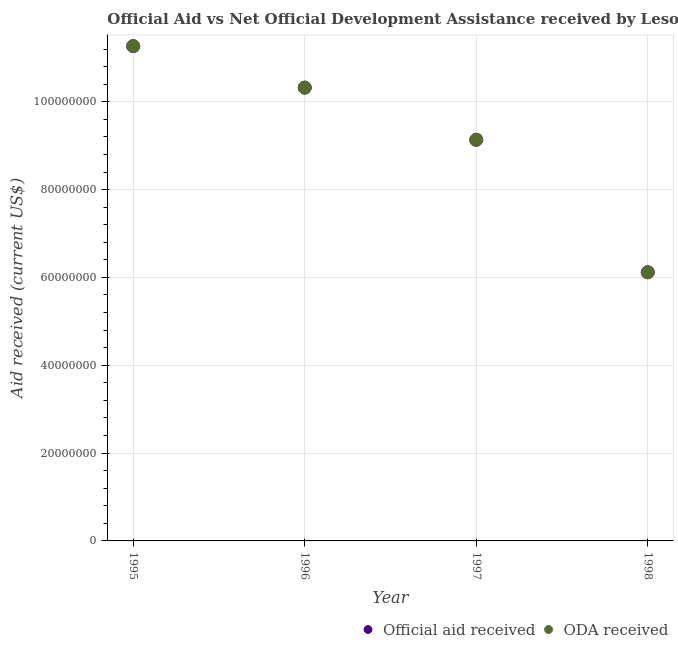Is the number of dotlines equal to the number of legend labels?
Ensure brevity in your answer.  Yes. What is the oda received in 1996?
Your answer should be compact. 1.03e+08. Across all years, what is the maximum oda received?
Your answer should be compact. 1.13e+08. Across all years, what is the minimum oda received?
Ensure brevity in your answer.  6.12e+07. In which year was the oda received maximum?
Keep it short and to the point. 1995. In which year was the oda received minimum?
Keep it short and to the point. 1998. What is the total official aid received in the graph?
Your response must be concise. 3.68e+08. What is the difference between the official aid received in 1995 and that in 1996?
Provide a succinct answer. 9.44e+06. What is the difference between the oda received in 1997 and the official aid received in 1998?
Your answer should be very brief. 3.02e+07. What is the average oda received per year?
Offer a very short reply. 9.21e+07. In how many years, is the official aid received greater than 92000000 US$?
Offer a very short reply. 2. What is the ratio of the oda received in 1995 to that in 1996?
Provide a succinct answer. 1.09. What is the difference between the highest and the second highest oda received?
Your answer should be compact. 9.44e+06. What is the difference between the highest and the lowest oda received?
Provide a succinct answer. 5.15e+07. In how many years, is the official aid received greater than the average official aid received taken over all years?
Provide a short and direct response. 2. Is the sum of the oda received in 1995 and 1996 greater than the maximum official aid received across all years?
Your answer should be compact. Yes. Is the oda received strictly less than the official aid received over the years?
Give a very brief answer. No. How many dotlines are there?
Keep it short and to the point. 2. How many years are there in the graph?
Give a very brief answer. 4. What is the difference between two consecutive major ticks on the Y-axis?
Give a very brief answer. 2.00e+07. Are the values on the major ticks of Y-axis written in scientific E-notation?
Provide a succinct answer. No. Does the graph contain grids?
Ensure brevity in your answer.  Yes. Where does the legend appear in the graph?
Your response must be concise. Bottom right. How many legend labels are there?
Provide a succinct answer. 2. How are the legend labels stacked?
Make the answer very short. Horizontal. What is the title of the graph?
Give a very brief answer. Official Aid vs Net Official Development Assistance received by Lesotho . What is the label or title of the Y-axis?
Ensure brevity in your answer.  Aid received (current US$). What is the Aid received (current US$) in Official aid received in 1995?
Your response must be concise. 1.13e+08. What is the Aid received (current US$) of ODA received in 1995?
Keep it short and to the point. 1.13e+08. What is the Aid received (current US$) of Official aid received in 1996?
Offer a terse response. 1.03e+08. What is the Aid received (current US$) of ODA received in 1996?
Offer a terse response. 1.03e+08. What is the Aid received (current US$) in Official aid received in 1997?
Provide a succinct answer. 9.13e+07. What is the Aid received (current US$) of ODA received in 1997?
Your answer should be compact. 9.13e+07. What is the Aid received (current US$) of Official aid received in 1998?
Offer a terse response. 6.12e+07. What is the Aid received (current US$) in ODA received in 1998?
Your response must be concise. 6.12e+07. Across all years, what is the maximum Aid received (current US$) in Official aid received?
Your answer should be very brief. 1.13e+08. Across all years, what is the maximum Aid received (current US$) in ODA received?
Offer a very short reply. 1.13e+08. Across all years, what is the minimum Aid received (current US$) in Official aid received?
Provide a short and direct response. 6.12e+07. Across all years, what is the minimum Aid received (current US$) of ODA received?
Offer a very short reply. 6.12e+07. What is the total Aid received (current US$) of Official aid received in the graph?
Offer a terse response. 3.68e+08. What is the total Aid received (current US$) of ODA received in the graph?
Provide a succinct answer. 3.68e+08. What is the difference between the Aid received (current US$) in Official aid received in 1995 and that in 1996?
Your answer should be compact. 9.44e+06. What is the difference between the Aid received (current US$) in ODA received in 1995 and that in 1996?
Your response must be concise. 9.44e+06. What is the difference between the Aid received (current US$) in Official aid received in 1995 and that in 1997?
Make the answer very short. 2.13e+07. What is the difference between the Aid received (current US$) in ODA received in 1995 and that in 1997?
Your answer should be very brief. 2.13e+07. What is the difference between the Aid received (current US$) in Official aid received in 1995 and that in 1998?
Your answer should be very brief. 5.15e+07. What is the difference between the Aid received (current US$) of ODA received in 1995 and that in 1998?
Provide a succinct answer. 5.15e+07. What is the difference between the Aid received (current US$) in Official aid received in 1996 and that in 1997?
Ensure brevity in your answer.  1.19e+07. What is the difference between the Aid received (current US$) in ODA received in 1996 and that in 1997?
Keep it short and to the point. 1.19e+07. What is the difference between the Aid received (current US$) in Official aid received in 1996 and that in 1998?
Make the answer very short. 4.20e+07. What is the difference between the Aid received (current US$) of ODA received in 1996 and that in 1998?
Keep it short and to the point. 4.20e+07. What is the difference between the Aid received (current US$) of Official aid received in 1997 and that in 1998?
Keep it short and to the point. 3.02e+07. What is the difference between the Aid received (current US$) in ODA received in 1997 and that in 1998?
Your response must be concise. 3.02e+07. What is the difference between the Aid received (current US$) of Official aid received in 1995 and the Aid received (current US$) of ODA received in 1996?
Provide a short and direct response. 9.44e+06. What is the difference between the Aid received (current US$) in Official aid received in 1995 and the Aid received (current US$) in ODA received in 1997?
Your answer should be very brief. 2.13e+07. What is the difference between the Aid received (current US$) in Official aid received in 1995 and the Aid received (current US$) in ODA received in 1998?
Keep it short and to the point. 5.15e+07. What is the difference between the Aid received (current US$) of Official aid received in 1996 and the Aid received (current US$) of ODA received in 1997?
Your response must be concise. 1.19e+07. What is the difference between the Aid received (current US$) of Official aid received in 1996 and the Aid received (current US$) of ODA received in 1998?
Offer a terse response. 4.20e+07. What is the difference between the Aid received (current US$) in Official aid received in 1997 and the Aid received (current US$) in ODA received in 1998?
Offer a very short reply. 3.02e+07. What is the average Aid received (current US$) of Official aid received per year?
Ensure brevity in your answer.  9.21e+07. What is the average Aid received (current US$) of ODA received per year?
Give a very brief answer. 9.21e+07. In the year 1997, what is the difference between the Aid received (current US$) in Official aid received and Aid received (current US$) in ODA received?
Keep it short and to the point. 0. What is the ratio of the Aid received (current US$) of Official aid received in 1995 to that in 1996?
Make the answer very short. 1.09. What is the ratio of the Aid received (current US$) in ODA received in 1995 to that in 1996?
Your answer should be very brief. 1.09. What is the ratio of the Aid received (current US$) in Official aid received in 1995 to that in 1997?
Your answer should be compact. 1.23. What is the ratio of the Aid received (current US$) of ODA received in 1995 to that in 1997?
Provide a succinct answer. 1.23. What is the ratio of the Aid received (current US$) in Official aid received in 1995 to that in 1998?
Offer a terse response. 1.84. What is the ratio of the Aid received (current US$) of ODA received in 1995 to that in 1998?
Offer a terse response. 1.84. What is the ratio of the Aid received (current US$) in Official aid received in 1996 to that in 1997?
Ensure brevity in your answer.  1.13. What is the ratio of the Aid received (current US$) in ODA received in 1996 to that in 1997?
Provide a succinct answer. 1.13. What is the ratio of the Aid received (current US$) in Official aid received in 1996 to that in 1998?
Make the answer very short. 1.69. What is the ratio of the Aid received (current US$) of ODA received in 1996 to that in 1998?
Your response must be concise. 1.69. What is the ratio of the Aid received (current US$) in Official aid received in 1997 to that in 1998?
Offer a very short reply. 1.49. What is the ratio of the Aid received (current US$) in ODA received in 1997 to that in 1998?
Provide a succinct answer. 1.49. What is the difference between the highest and the second highest Aid received (current US$) in Official aid received?
Offer a terse response. 9.44e+06. What is the difference between the highest and the second highest Aid received (current US$) of ODA received?
Make the answer very short. 9.44e+06. What is the difference between the highest and the lowest Aid received (current US$) in Official aid received?
Provide a succinct answer. 5.15e+07. What is the difference between the highest and the lowest Aid received (current US$) of ODA received?
Offer a very short reply. 5.15e+07. 